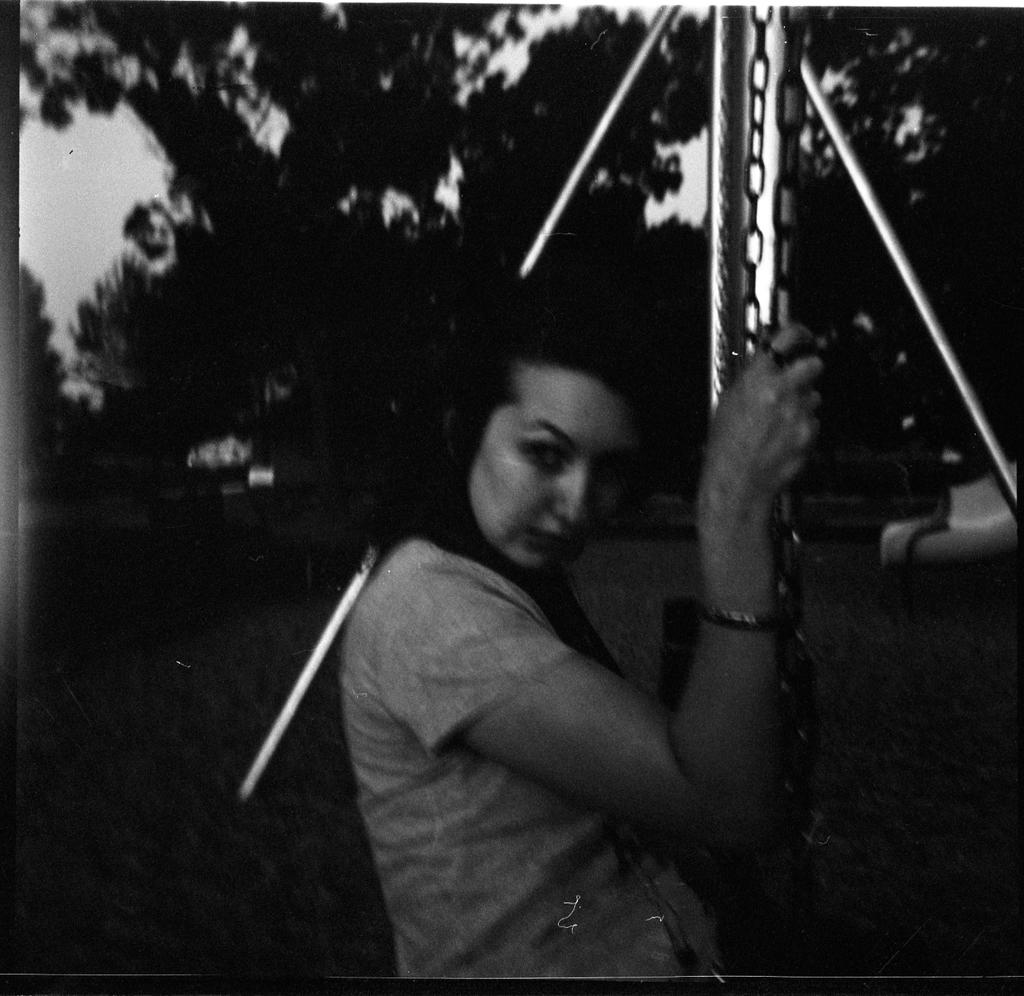Who is present in the image? There is a woman in the image. What is the woman holding in the image? The woman is holding chains in the image. What type of vegetation can be seen in the image? There are plants and trees in the image. How would you describe the sky in the image? The sky is cloudy in the image. What type of creature is using a quill to write a message in the image? There is no creature present in the image, nor is there any writing or quill visible. 